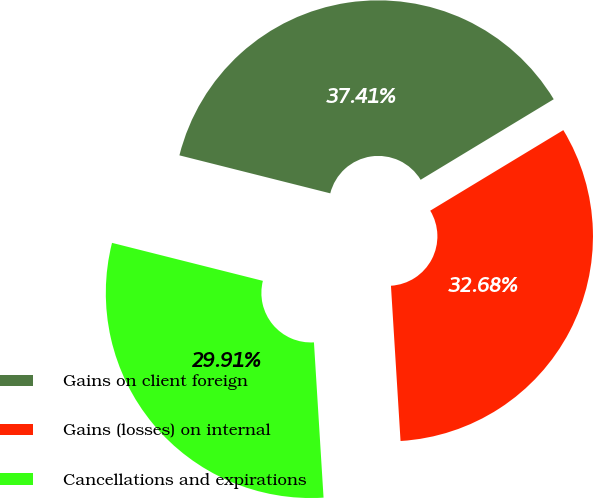Convert chart. <chart><loc_0><loc_0><loc_500><loc_500><pie_chart><fcel>Gains on client foreign<fcel>Gains (losses) on internal<fcel>Cancellations and expirations<nl><fcel>37.41%<fcel>32.68%<fcel>29.91%<nl></chart> 